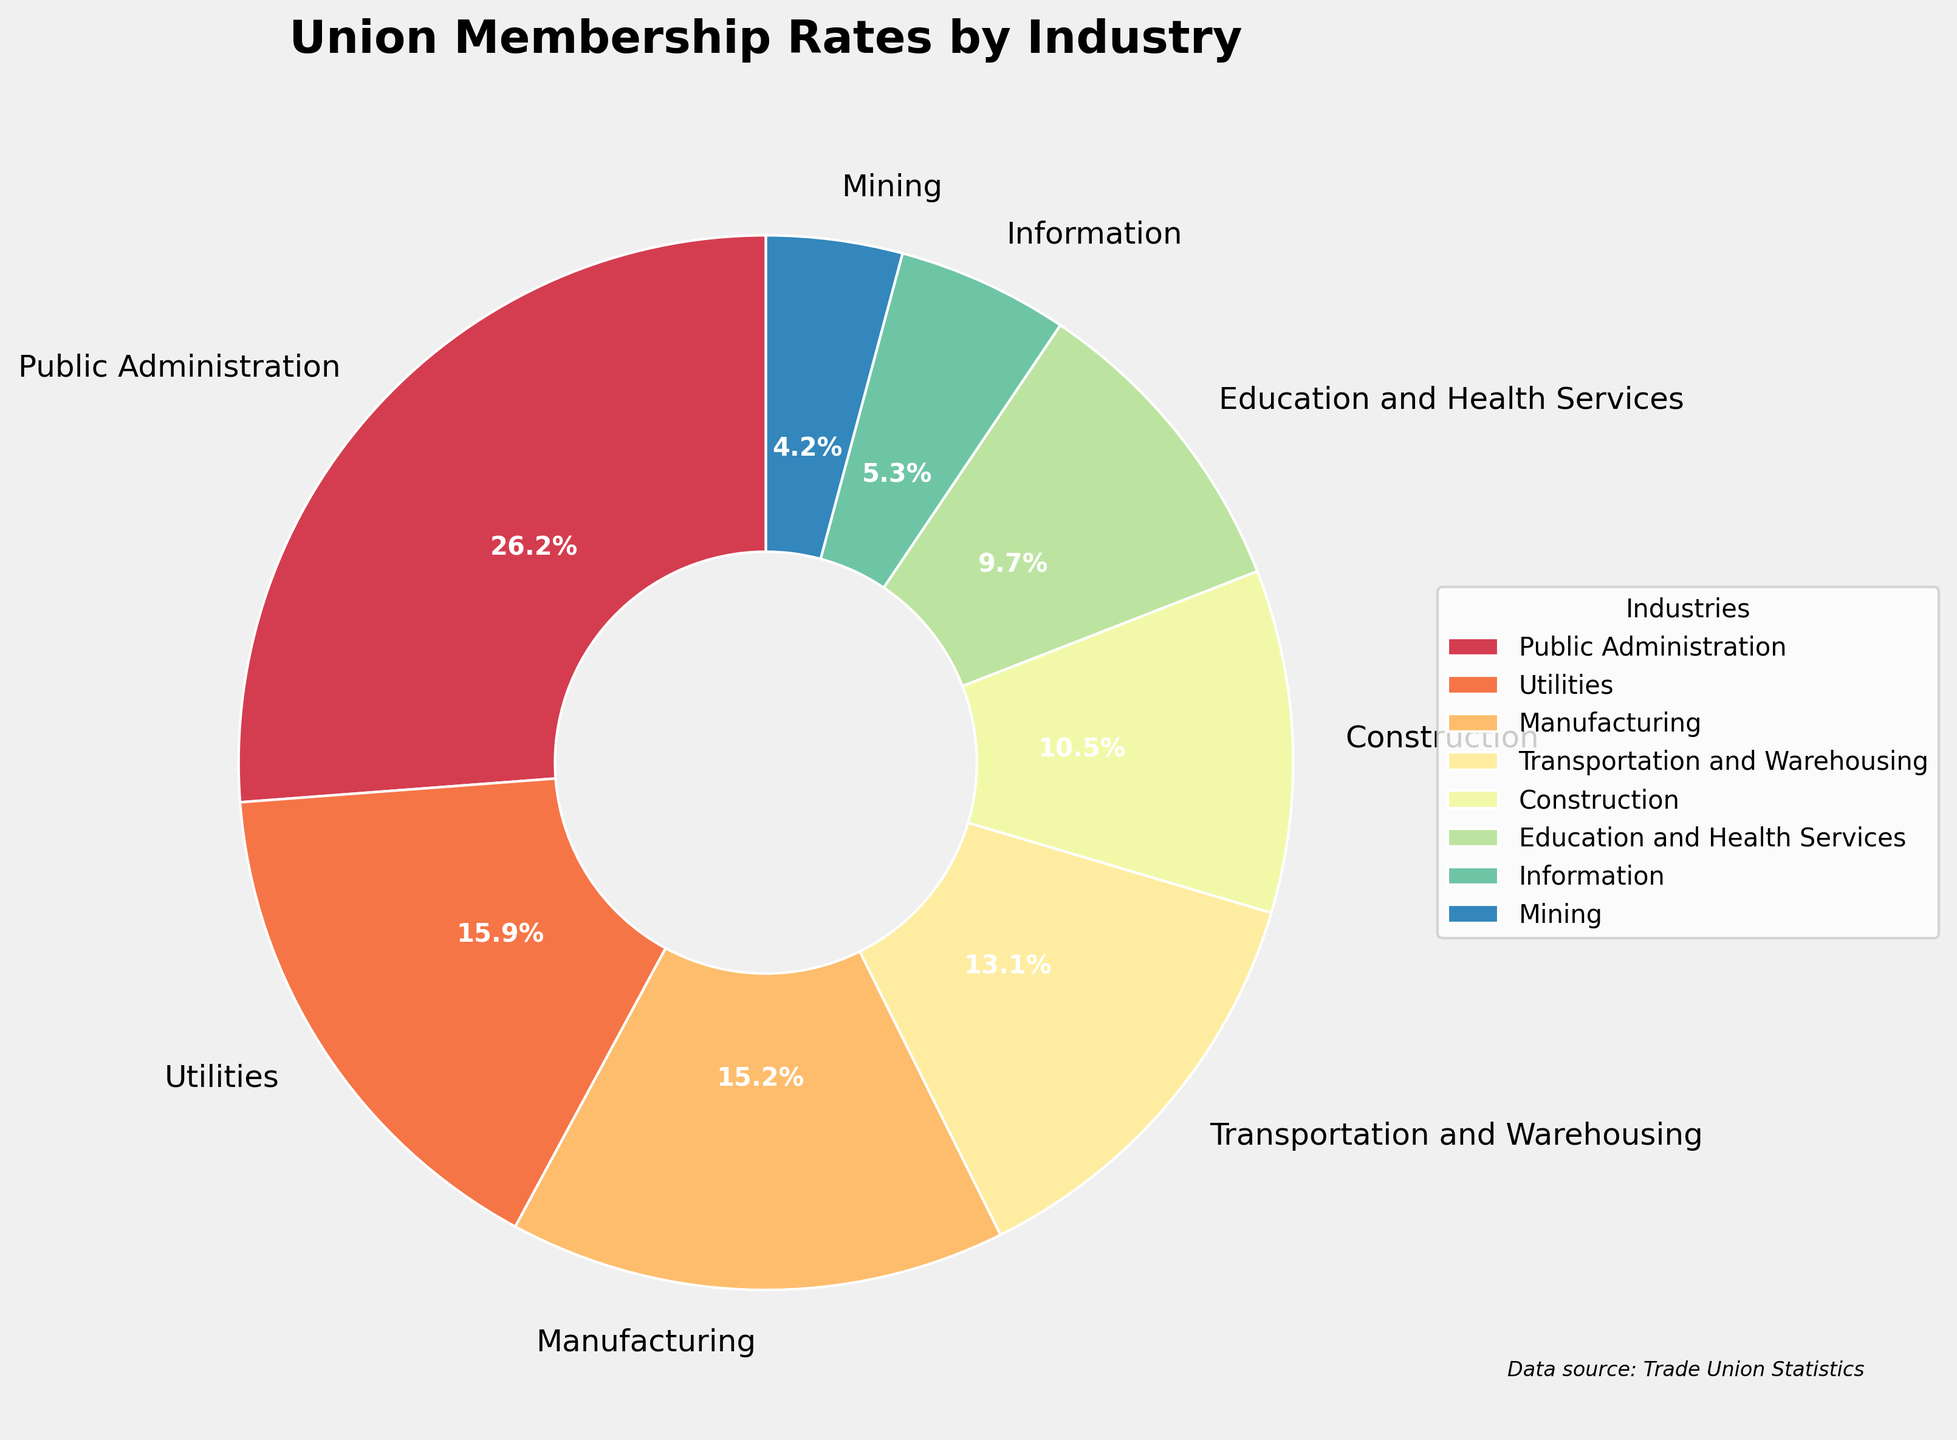What's the industry with the highest union membership rate? To find the industry with the highest union membership rate, look for the largest slice of the pie chart. The industry with the largest slice has the highest rate.
Answer: Public Administration Which industry has the lowest union membership rate among the top 8 industries? Identify the smallest slice in the pie chart from the top 8 industries, as the smallest slice represents the lowest rate.
Answer: Education and Health Services What is the combined union membership rate for Public Administration and Utilities? Add the union membership rates of Public Administration and Utilities together. According to the figure, Public Administration is 33.9% and Utilities is 20.6%. Thus, 33.9 + 20.6 = 54.5%.
Answer: 54.5% How does the union membership rate in Manufacturing compare to that in Construction? Locate the slices for Manufacturing and Construction and compare their sizes. Manufacturing has a rate of 19.7%, while Construction has a rate of 13.6%. Therefore, 19.7% is greater than 13.6%.
Answer: Manufacturing has a higher rate than Construction Is the union membership rate in Education and Health Services closer to that in Transportation and Warehousing or in Construction? Compare the union membership rate of Education and Health Services (12.5%) with the rates of Transportation and Warehousing (16.9%) and Construction (13.6%). The difference between Education and Health Services and Transportation and Warehousing is 16.9 - 12.5 = 4.4, while the difference between Education and Health Services and Construction is 13.6 - 12.5 = 1.1. Since 1.1 is smaller than 4.4, it is closer to Construction.
Answer: Construction What is the average union membership rate for Manufacturing, Construction, and Transportation and Warehousing? First, sum the union membership rates for Manufacturing (19.7%), Construction (13.6%), and Transportation and Warehousing (16.9%). Then divide by the number of industries: (19.7 + 13.6 + 16.9) / 3 = 50.2 / 3 = 16.73.
Answer: 16.73% Which industry, apart from Public Administration, has a union membership rate above 20%? Look at the pie slices other than Public Administration and identify if any have rates above 20%. Utilities has a union membership rate of 20.6%, which is above 20%.
Answer: Utilities What is the difference in union membership rate between the industry with the highest rate and the one with the second-highest rate? Identify the two largest slices in the pie chart. The highest rate is Public Administration at 33.9%, and the second-highest rate is Utilities at 20.6%. Subtract the second-highest rate from the highest rate: 33.9 - 20.6 = 13.3.
Answer: 13.3 